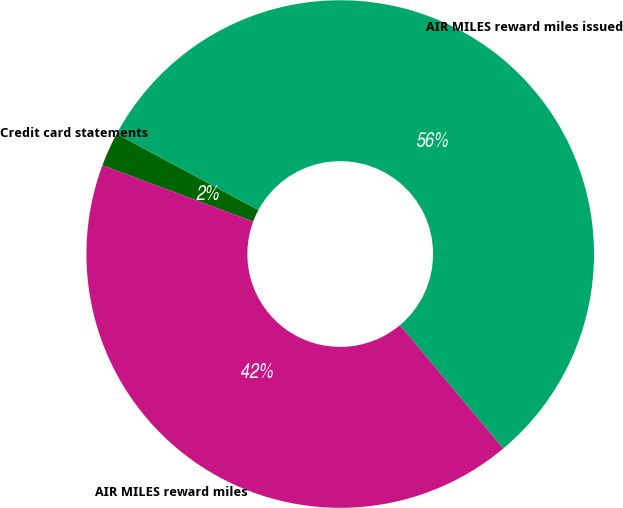Convert chart. <chart><loc_0><loc_0><loc_500><loc_500><pie_chart><fcel>Credit card statements<fcel>AIR MILES reward miles issued<fcel>AIR MILES reward miles<nl><fcel>2.16%<fcel>56.05%<fcel>41.79%<nl></chart> 